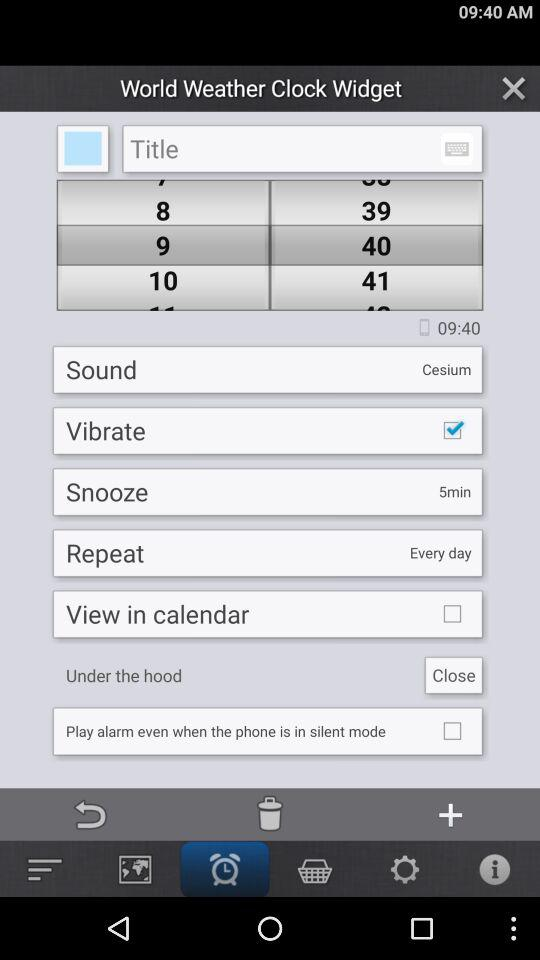Which option is selected at the taskbar? The selected option is "Alarm". 